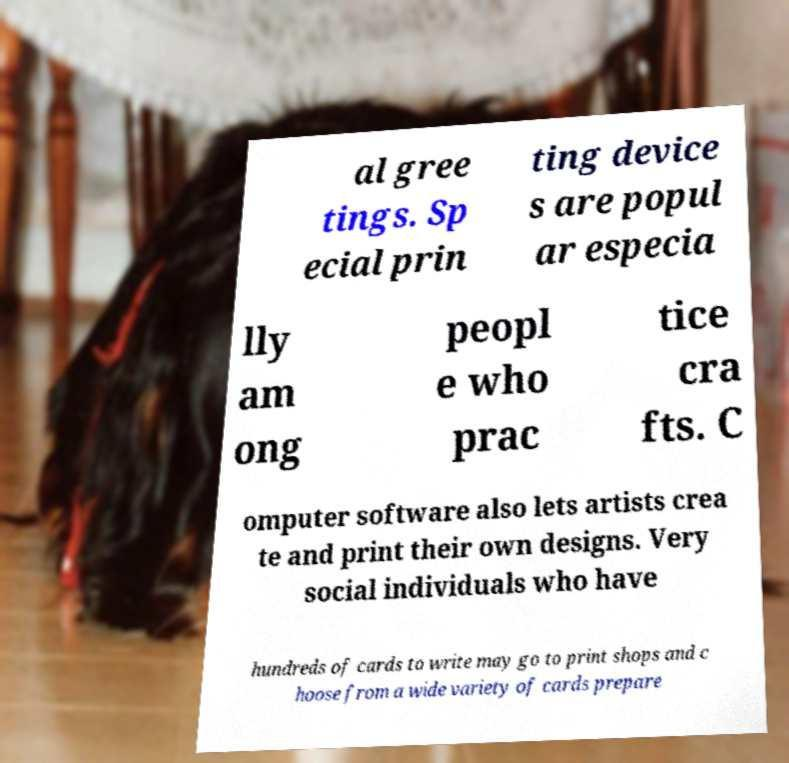There's text embedded in this image that I need extracted. Can you transcribe it verbatim? al gree tings. Sp ecial prin ting device s are popul ar especia lly am ong peopl e who prac tice cra fts. C omputer software also lets artists crea te and print their own designs. Very social individuals who have hundreds of cards to write may go to print shops and c hoose from a wide variety of cards prepare 